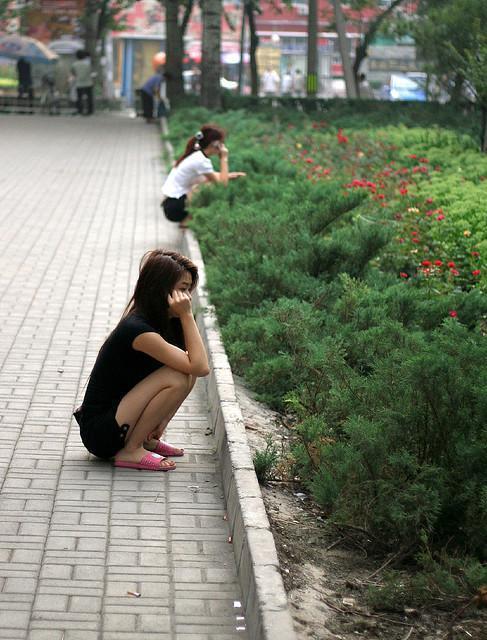How many people are there?
Give a very brief answer. 2. How many chairs are there?
Give a very brief answer. 0. 